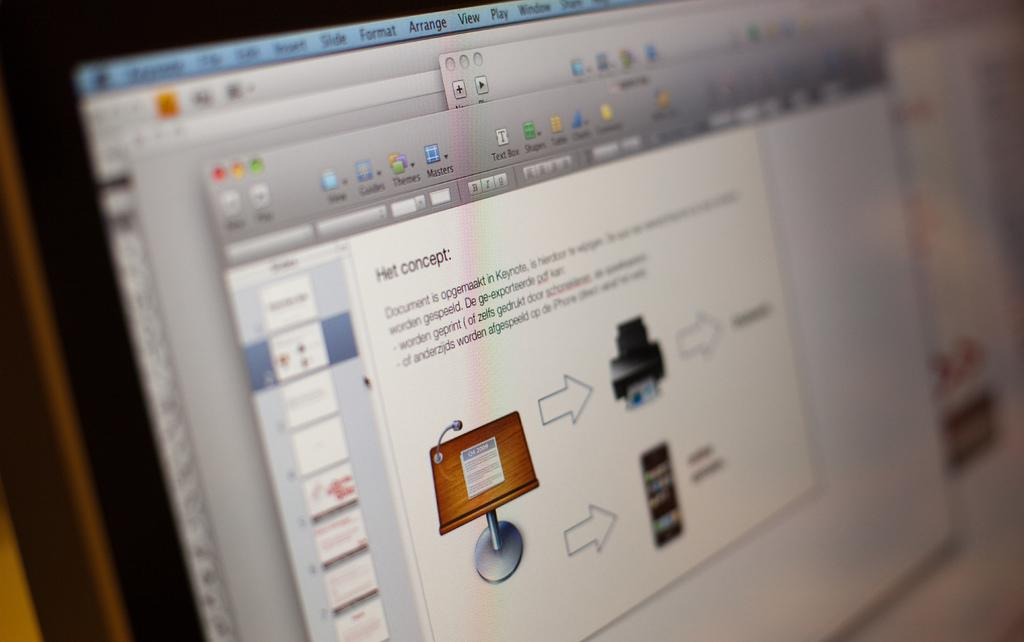<image>
Give a short and clear explanation of the subsequent image. a computer screen with an open tab that says 'het concept:' on it 